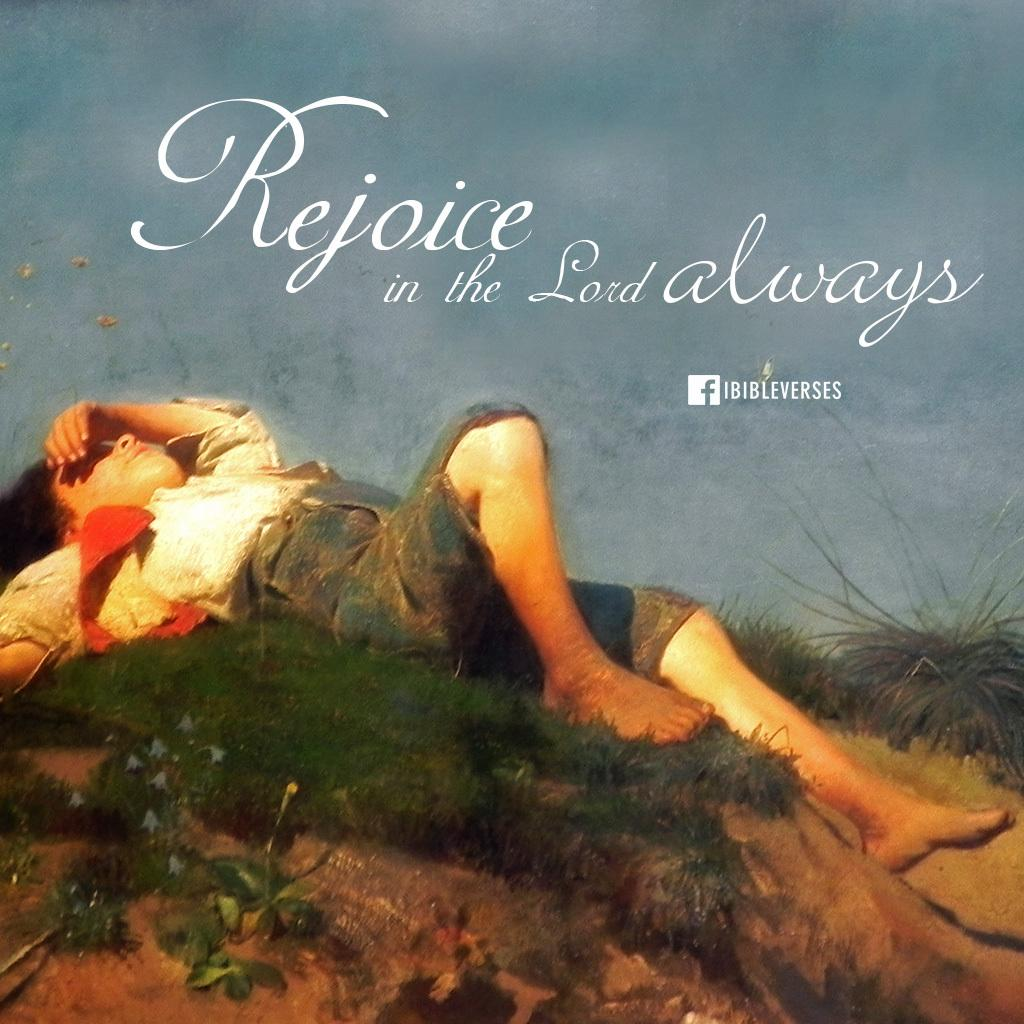<image>
Summarize the visual content of the image. Rejoice in the Lord always from Fibibleverses book cover. 